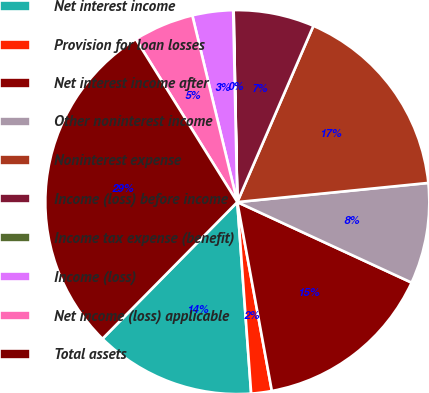Convert chart. <chart><loc_0><loc_0><loc_500><loc_500><pie_chart><fcel>Net interest income<fcel>Provision for loan losses<fcel>Net interest income after<fcel>Other noninterest income<fcel>Noninterest expense<fcel>Income (loss) before income<fcel>Income tax expense (benefit)<fcel>Income (loss)<fcel>Net income (loss) applicable<fcel>Total assets<nl><fcel>13.54%<fcel>1.73%<fcel>15.23%<fcel>8.48%<fcel>16.92%<fcel>6.79%<fcel>0.04%<fcel>3.42%<fcel>5.1%<fcel>28.74%<nl></chart> 